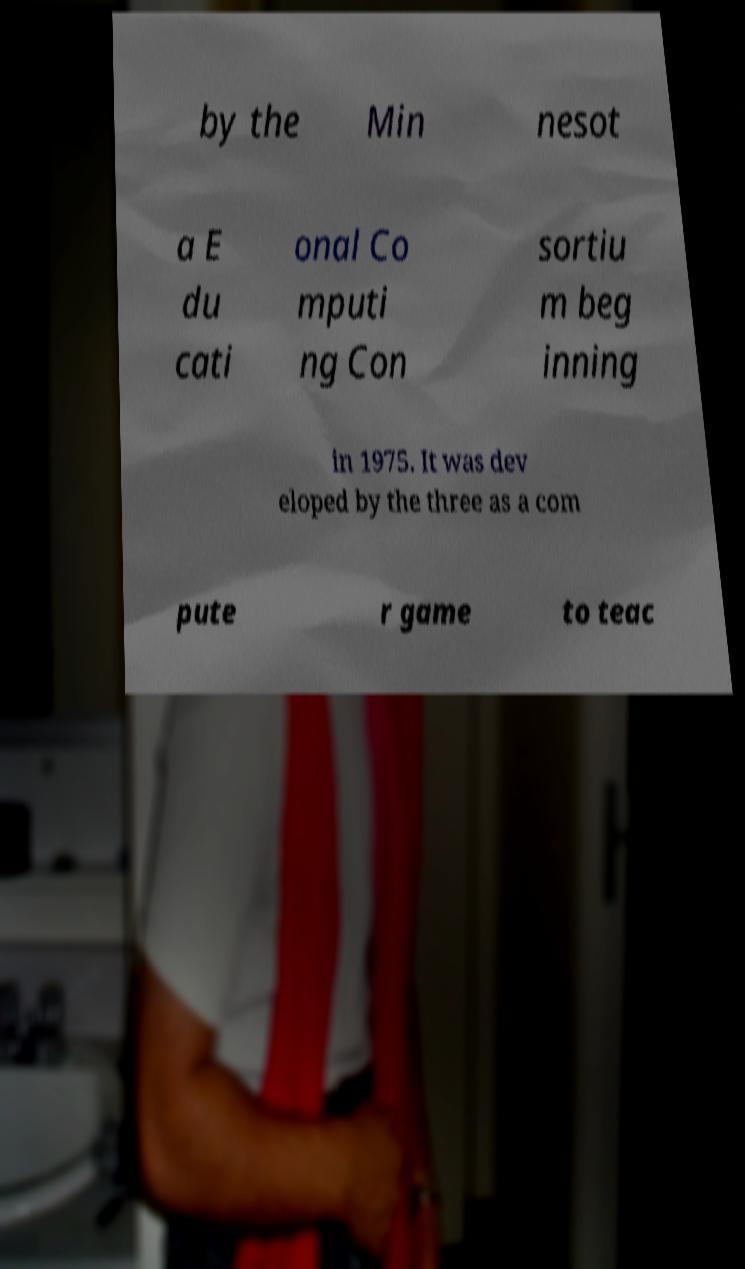Can you read and provide the text displayed in the image?This photo seems to have some interesting text. Can you extract and type it out for me? by the Min nesot a E du cati onal Co mputi ng Con sortiu m beg inning in 1975. It was dev eloped by the three as a com pute r game to teac 